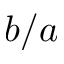Convert formula to latex. <formula><loc_0><loc_0><loc_500><loc_500>b / a</formula> 